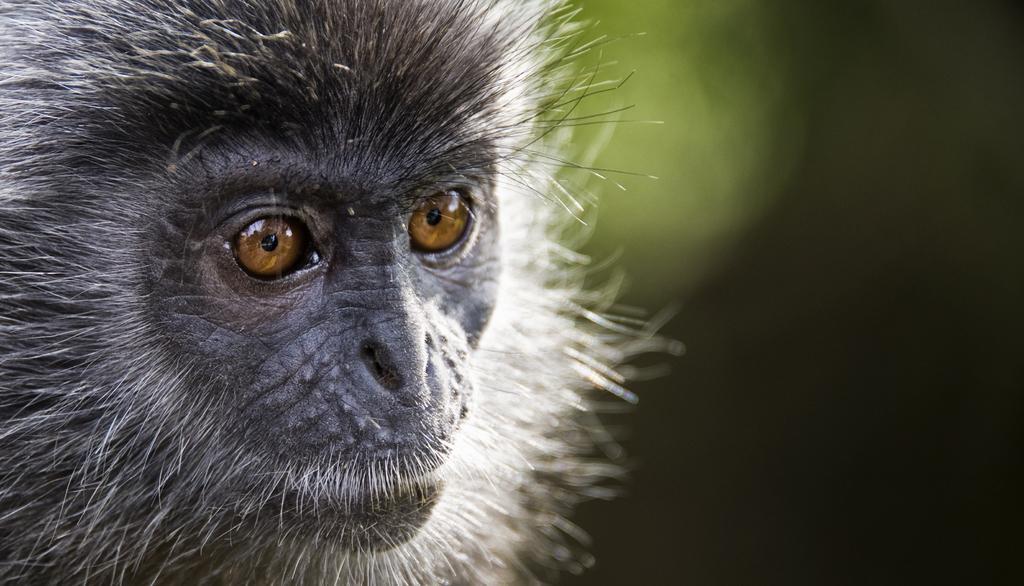How would you summarize this image in a sentence or two? In the image we can see a animal. Background of the image is blur. 